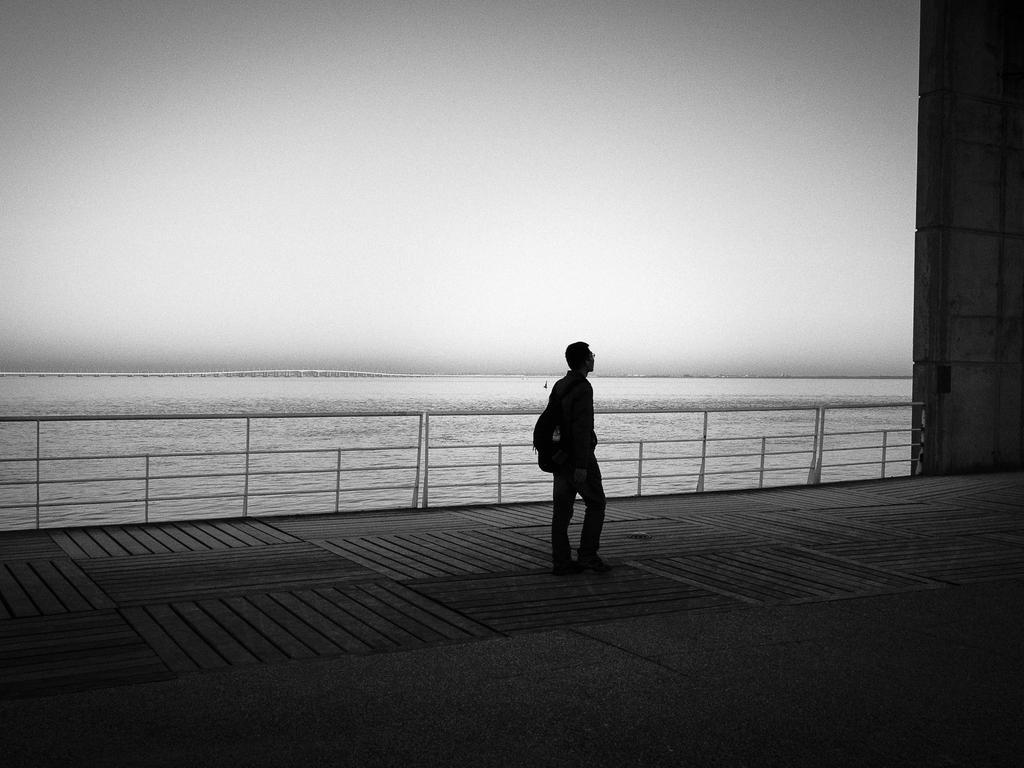Could you give a brief overview of what you see in this image? It is a black and white image. In this image, we can see a person is wearing a backpack and walking on the surface. On the right side, we can see wall and some object. Here there is a railing. Background we can see water and sky. 